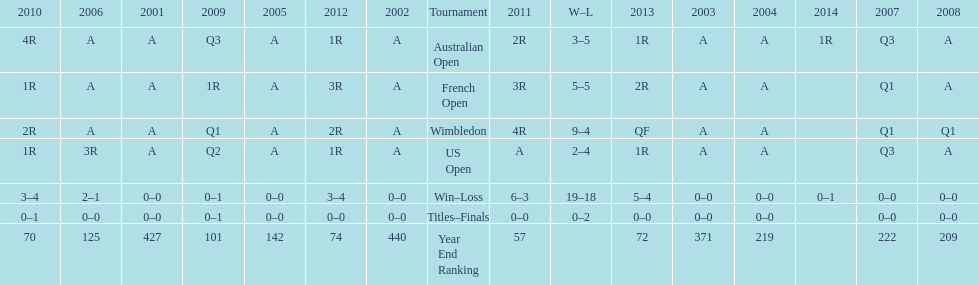Could you help me parse every detail presented in this table? {'header': ['2010', '2006', '2001', '2009', '2005', '2012', '2002', 'Tournament', '2011', 'W–L', '2013', '2003', '2004', '2014', '2007', '2008'], 'rows': [['4R', 'A', 'A', 'Q3', 'A', '1R', 'A', 'Australian Open', '2R', '3–5', '1R', 'A', 'A', '1R', 'Q3', 'A'], ['1R', 'A', 'A', '1R', 'A', '3R', 'A', 'French Open', '3R', '5–5', '2R', 'A', 'A', '', 'Q1', 'A'], ['2R', 'A', 'A', 'Q1', 'A', '2R', 'A', 'Wimbledon', '4R', '9–4', 'QF', 'A', 'A', '', 'Q1', 'Q1'], ['1R', '3R', 'A', 'Q2', 'A', '1R', 'A', 'US Open', 'A', '2–4', '1R', 'A', 'A', '', 'Q3', 'A'], ['3–4', '2–1', '0–0', '0–1', '0–0', '3–4', '0–0', 'Win–Loss', '6–3', '19–18', '5–4', '0–0', '0–0', '0–1', '0–0', '0–0'], ['0–1', '0–0', '0–0', '0–1', '0–0', '0–0', '0–0', 'Titles–Finals', '0–0', '0–2', '0–0', '0–0', '0–0', '', '0–0', '0–0'], ['70', '125', '427', '101', '142', '74', '440', 'Year End Ranking', '57', '', '72', '371', '219', '', '222', '209']]} What was this players average ranking between 2001 and 2006? 287. 